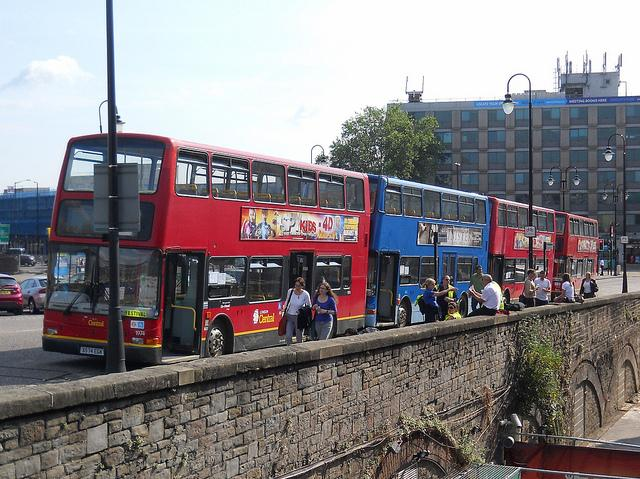Who is the queen of this territory? elizabeth ii 